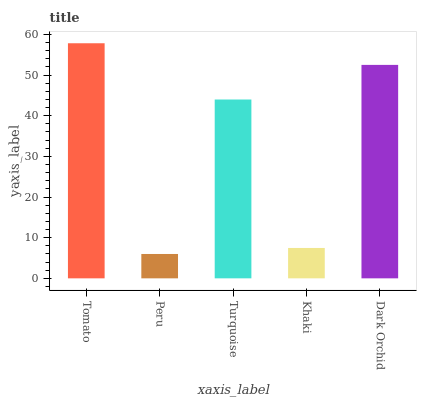Is Peru the minimum?
Answer yes or no. Yes. Is Tomato the maximum?
Answer yes or no. Yes. Is Turquoise the minimum?
Answer yes or no. No. Is Turquoise the maximum?
Answer yes or no. No. Is Turquoise greater than Peru?
Answer yes or no. Yes. Is Peru less than Turquoise?
Answer yes or no. Yes. Is Peru greater than Turquoise?
Answer yes or no. No. Is Turquoise less than Peru?
Answer yes or no. No. Is Turquoise the high median?
Answer yes or no. Yes. Is Turquoise the low median?
Answer yes or no. Yes. Is Dark Orchid the high median?
Answer yes or no. No. Is Tomato the low median?
Answer yes or no. No. 